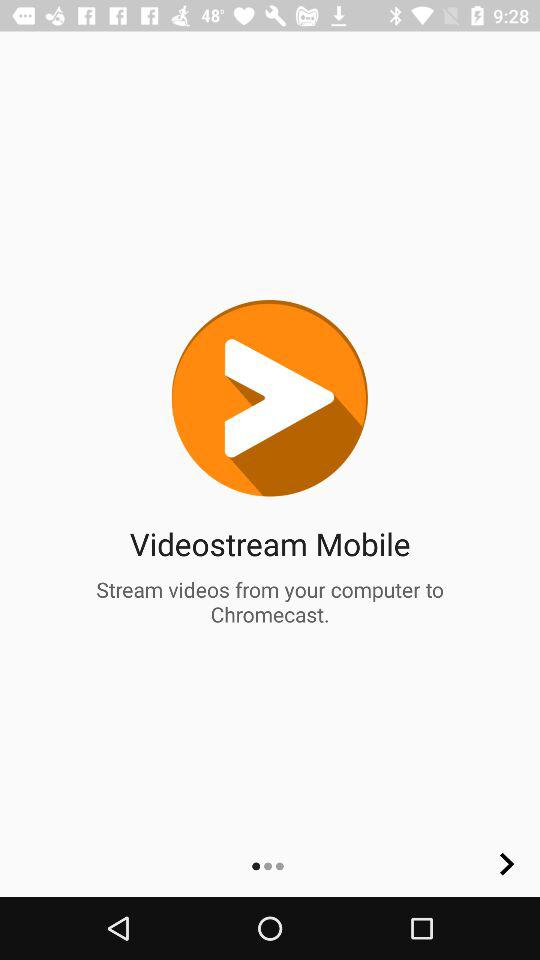What is the name of the application? The name of the application is "Videostream Mobile". 